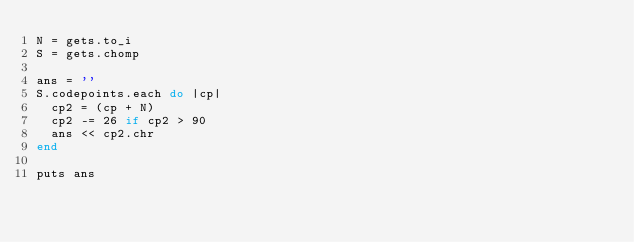<code> <loc_0><loc_0><loc_500><loc_500><_Ruby_>N = gets.to_i
S = gets.chomp

ans = ''
S.codepoints.each do |cp|
  cp2 = (cp + N)
  cp2 -= 26 if cp2 > 90
  ans << cp2.chr
end

puts ans
</code> 